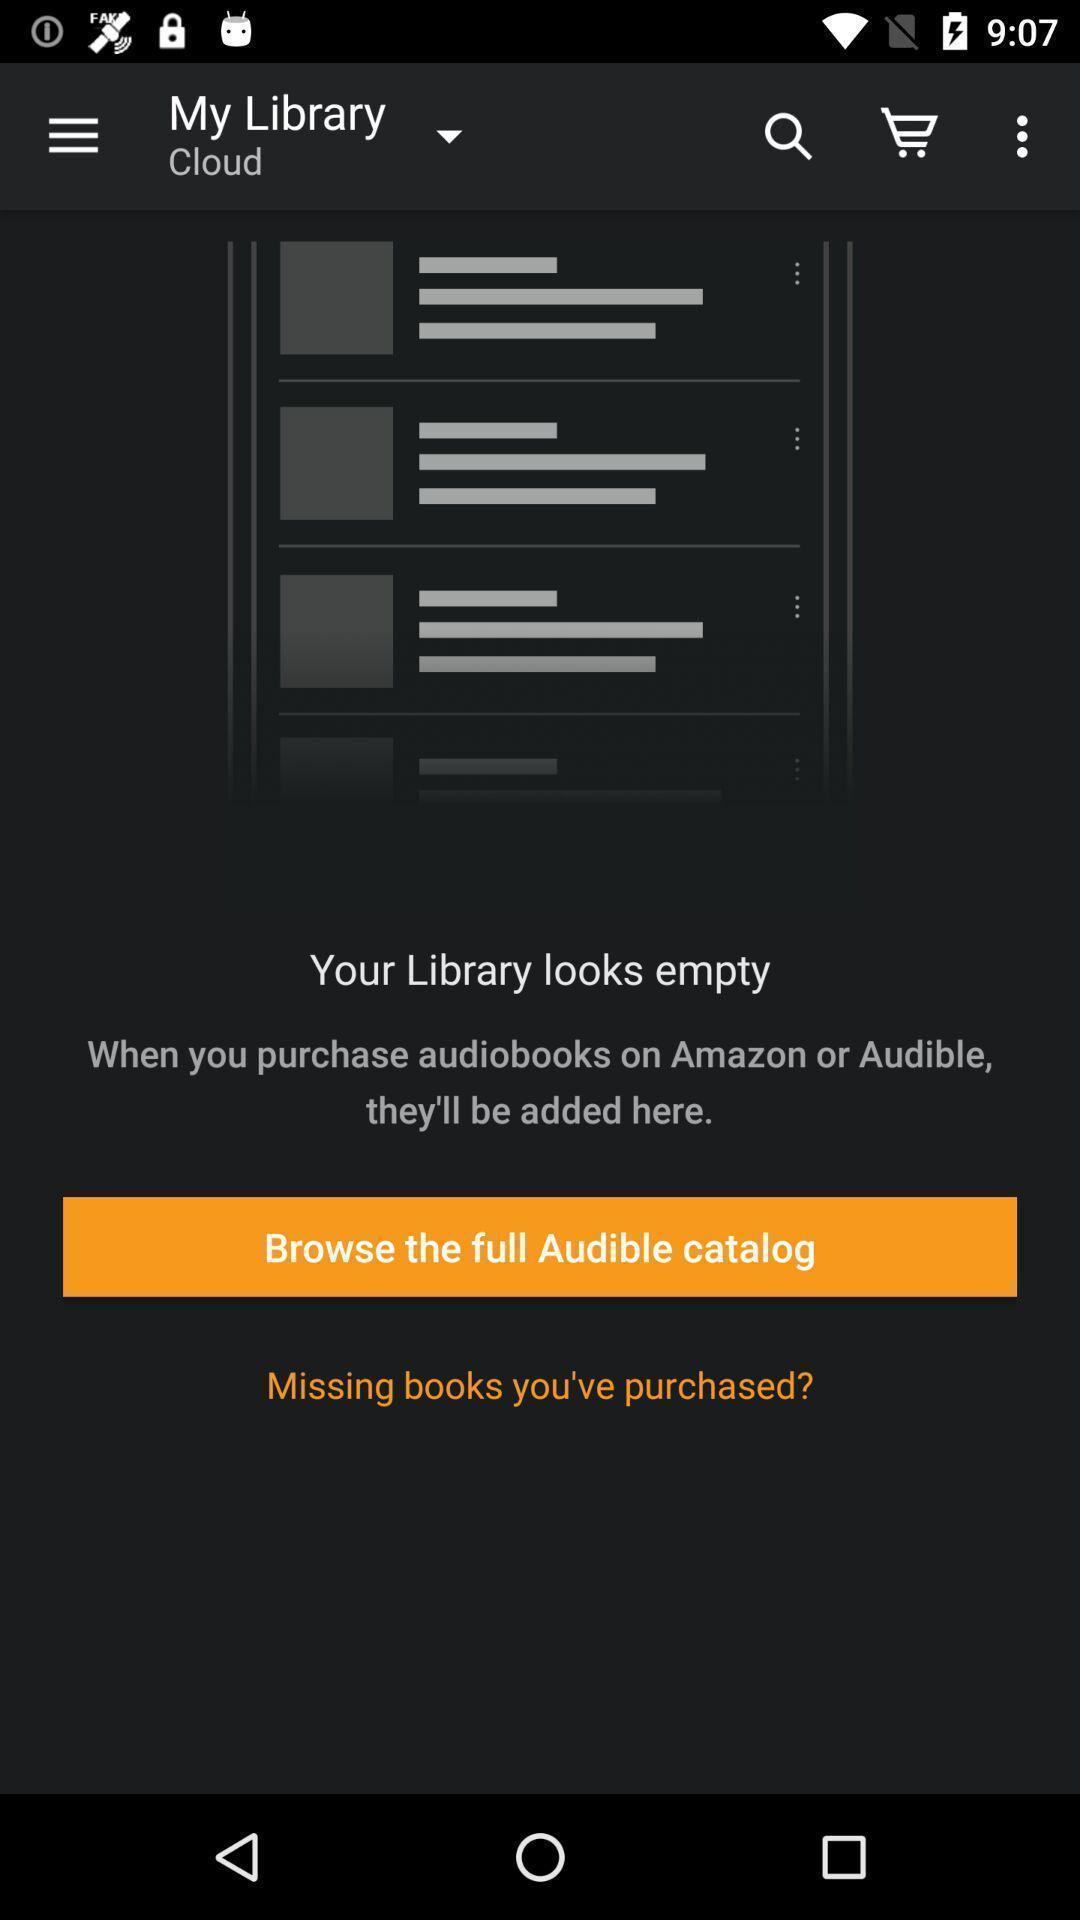Describe the key features of this screenshot. Page showing multiple options. 